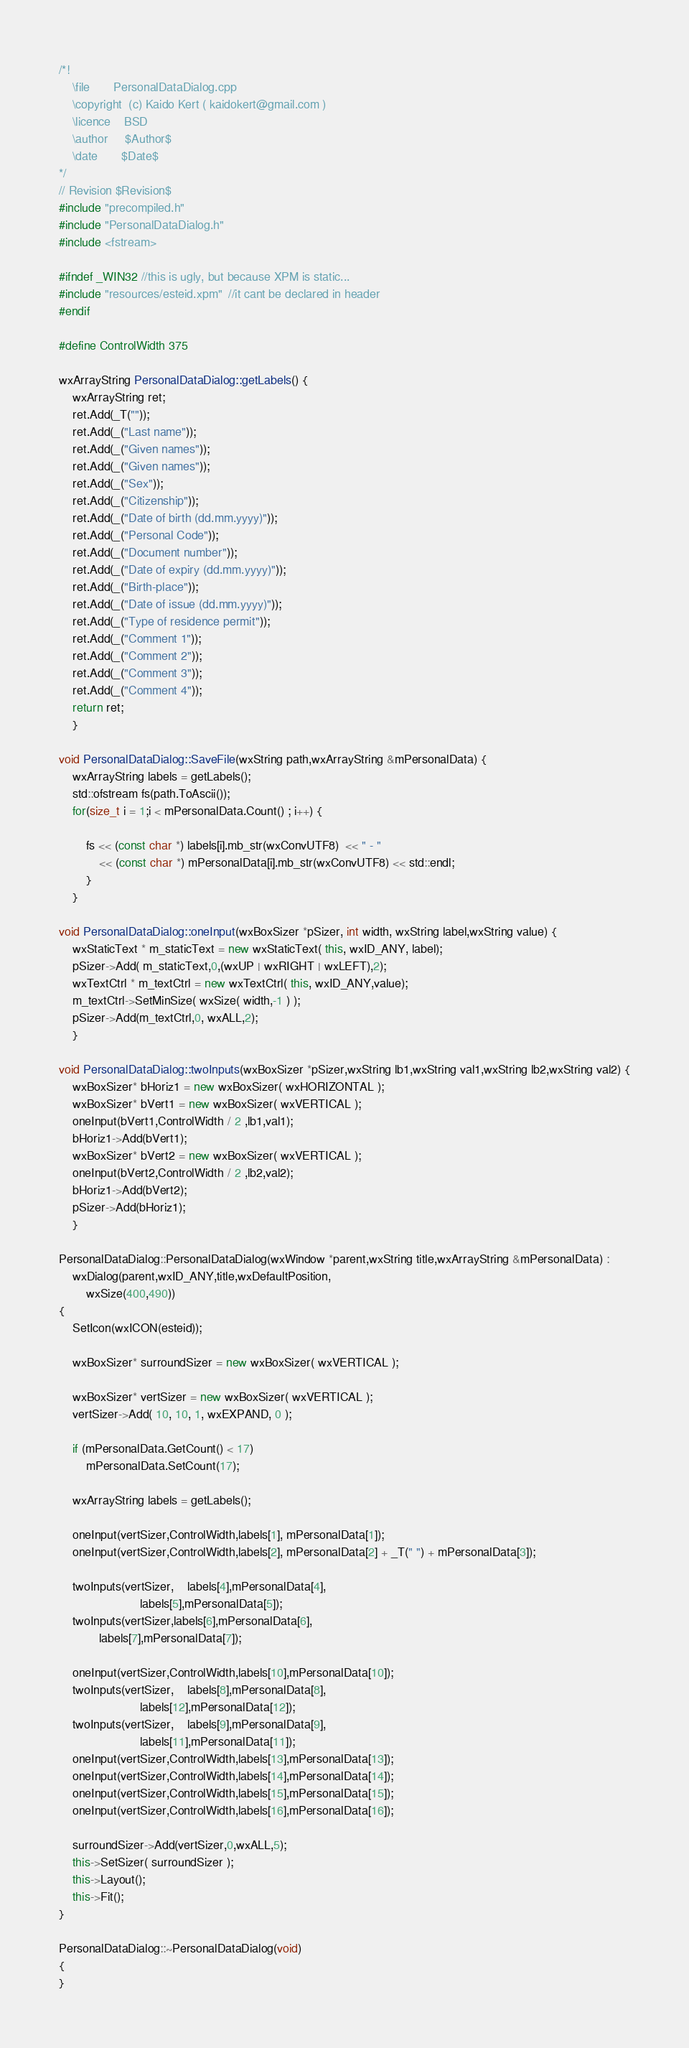Convert code to text. <code><loc_0><loc_0><loc_500><loc_500><_C++_>/*!
	\file		PersonalDataDialog.cpp
	\copyright	(c) Kaido Kert ( kaidokert@gmail.com )
	\licence	BSD
	\author		$Author$
	\date		$Date$
*/
// Revision $Revision$
#include "precompiled.h"
#include "PersonalDataDialog.h"
#include <fstream>

#ifndef _WIN32 //this is ugly, but because XPM is static...
#include "resources/esteid.xpm"  //it cant be declared in header
#endif

#define ControlWidth 375

wxArrayString PersonalDataDialog::getLabels() {
	wxArrayString ret;
	ret.Add(_T(""));
	ret.Add(_("Last name"));
	ret.Add(_("Given names"));
	ret.Add(_("Given names"));
	ret.Add(_("Sex"));
	ret.Add(_("Citizenship"));
	ret.Add(_("Date of birth (dd.mm.yyyy)"));
	ret.Add(_("Personal Code"));
	ret.Add(_("Document number"));
	ret.Add(_("Date of expiry (dd.mm.yyyy)"));
	ret.Add(_("Birth-place"));
	ret.Add(_("Date of issue (dd.mm.yyyy)"));
	ret.Add(_("Type of residence permit"));
	ret.Add(_("Comment 1"));
	ret.Add(_("Comment 2"));
	ret.Add(_("Comment 3"));
	ret.Add(_("Comment 4"));
	return ret;
	}

void PersonalDataDialog::SaveFile(wxString path,wxArrayString &mPersonalData) {
	wxArrayString labels = getLabels();
	std::ofstream fs(path.ToAscii());
	for(size_t i = 1;i < mPersonalData.Count() ; i++) {

		fs << (const char *) labels[i].mb_str(wxConvUTF8)  << " - "
            << (const char *) mPersonalData[i].mb_str(wxConvUTF8) << std::endl;
		}
	}

void PersonalDataDialog::oneInput(wxBoxSizer *pSizer, int width, wxString label,wxString value) {
	wxStaticText * m_staticText = new wxStaticText( this, wxID_ANY, label);
	pSizer->Add( m_staticText,0,(wxUP | wxRIGHT | wxLEFT),2);
	wxTextCtrl * m_textCtrl = new wxTextCtrl( this, wxID_ANY,value);
	m_textCtrl->SetMinSize( wxSize( width,-1 ) );
	pSizer->Add(m_textCtrl,0, wxALL,2);
	}

void PersonalDataDialog::twoInputs(wxBoxSizer *pSizer,wxString lb1,wxString val1,wxString lb2,wxString val2) {
	wxBoxSizer* bHoriz1 = new wxBoxSizer( wxHORIZONTAL );
	wxBoxSizer* bVert1 = new wxBoxSizer( wxVERTICAL );
	oneInput(bVert1,ControlWidth / 2 ,lb1,val1);
	bHoriz1->Add(bVert1);
	wxBoxSizer* bVert2 = new wxBoxSizer( wxVERTICAL );
	oneInput(bVert2,ControlWidth / 2 ,lb2,val2);
	bHoriz1->Add(bVert2);
	pSizer->Add(bHoriz1);
	}

PersonalDataDialog::PersonalDataDialog(wxWindow *parent,wxString title,wxArrayString &mPersonalData) :
	wxDialog(parent,wxID_ANY,title,wxDefaultPosition,
		wxSize(400,490))
{
	SetIcon(wxICON(esteid));

	wxBoxSizer* surroundSizer = new wxBoxSizer( wxVERTICAL );

	wxBoxSizer* vertSizer = new wxBoxSizer( wxVERTICAL );
	vertSizer->Add( 10, 10, 1, wxEXPAND, 0 );

	if (mPersonalData.GetCount() < 17)
		mPersonalData.SetCount(17);

	wxArrayString labels = getLabels();

	oneInput(vertSizer,ControlWidth,labels[1], mPersonalData[1]);
	oneInput(vertSizer,ControlWidth,labels[2], mPersonalData[2] + _T(" ") + mPersonalData[3]);

	twoInputs(vertSizer,	labels[4],mPersonalData[4],
						labels[5],mPersonalData[5]);
	twoInputs(vertSizer,labels[6],mPersonalData[6],
			labels[7],mPersonalData[7]);

	oneInput(vertSizer,ControlWidth,labels[10],mPersonalData[10]);
	twoInputs(vertSizer,	labels[8],mPersonalData[8],
						labels[12],mPersonalData[12]);
	twoInputs(vertSizer,	labels[9],mPersonalData[9],
						labels[11],mPersonalData[11]);
	oneInput(vertSizer,ControlWidth,labels[13],mPersonalData[13]);
	oneInput(vertSizer,ControlWidth,labels[14],mPersonalData[14]);
	oneInput(vertSizer,ControlWidth,labels[15],mPersonalData[15]);
	oneInput(vertSizer,ControlWidth,labels[16],mPersonalData[16]);

	surroundSizer->Add(vertSizer,0,wxALL,5);
	this->SetSizer( surroundSizer );
	this->Layout();
	this->Fit();
}

PersonalDataDialog::~PersonalDataDialog(void)
{
}
</code> 